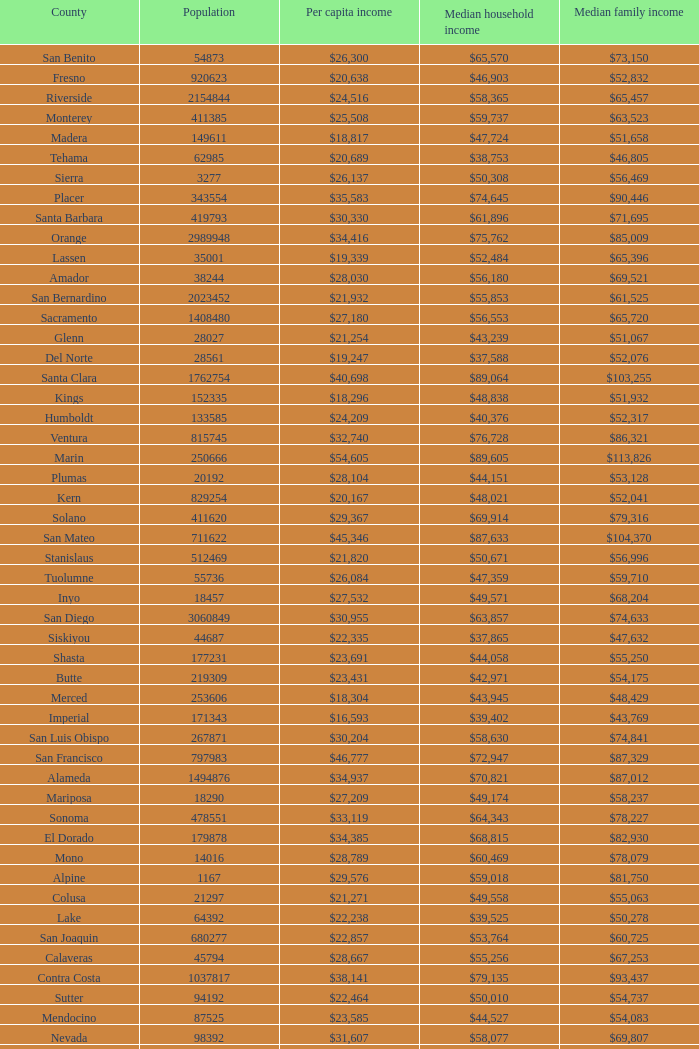What is the median household income of butte? $42,971. 